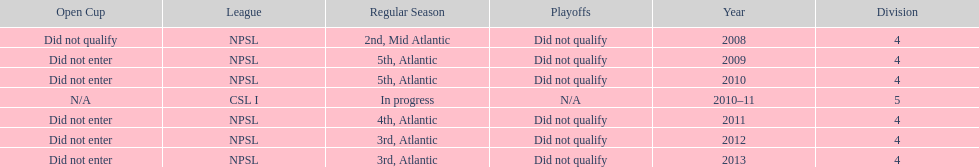After being 4th in the regular season, what was their final placement for the year? 3rd. 